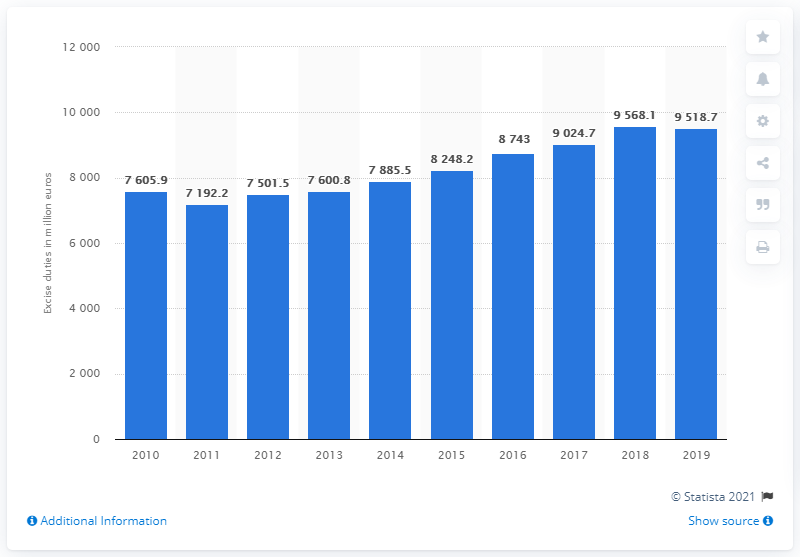Identify some key points in this picture. In 2019, the total revenue generated from excise duties in Belgium was 9518.7 million euros. 